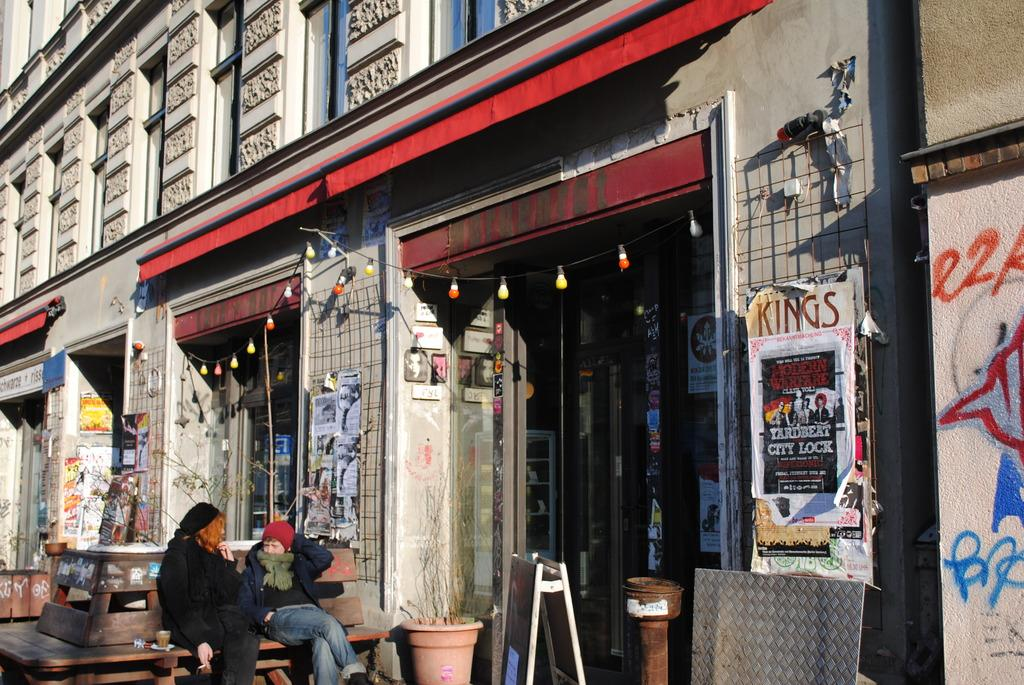What are the two people in the image doing? The two people are sitting on a bench in the image. What type of vegetation can be seen in the image? There are plants in pots in the image. What is attached to the wall in the image? There are papers pasted on a wall in the image. What type of lighting is present in the image? There are bulbs on a rope in the image. What type of structure is visible in the image? There is a building in the image. What other objects can be seen in the image? There are boards visible in the image. What type of honey is being collected from the sticks in the image? There are no sticks or honey present in the image. How many pins are visible on the boards in the image? There are no pins visible on the boards in the image. 